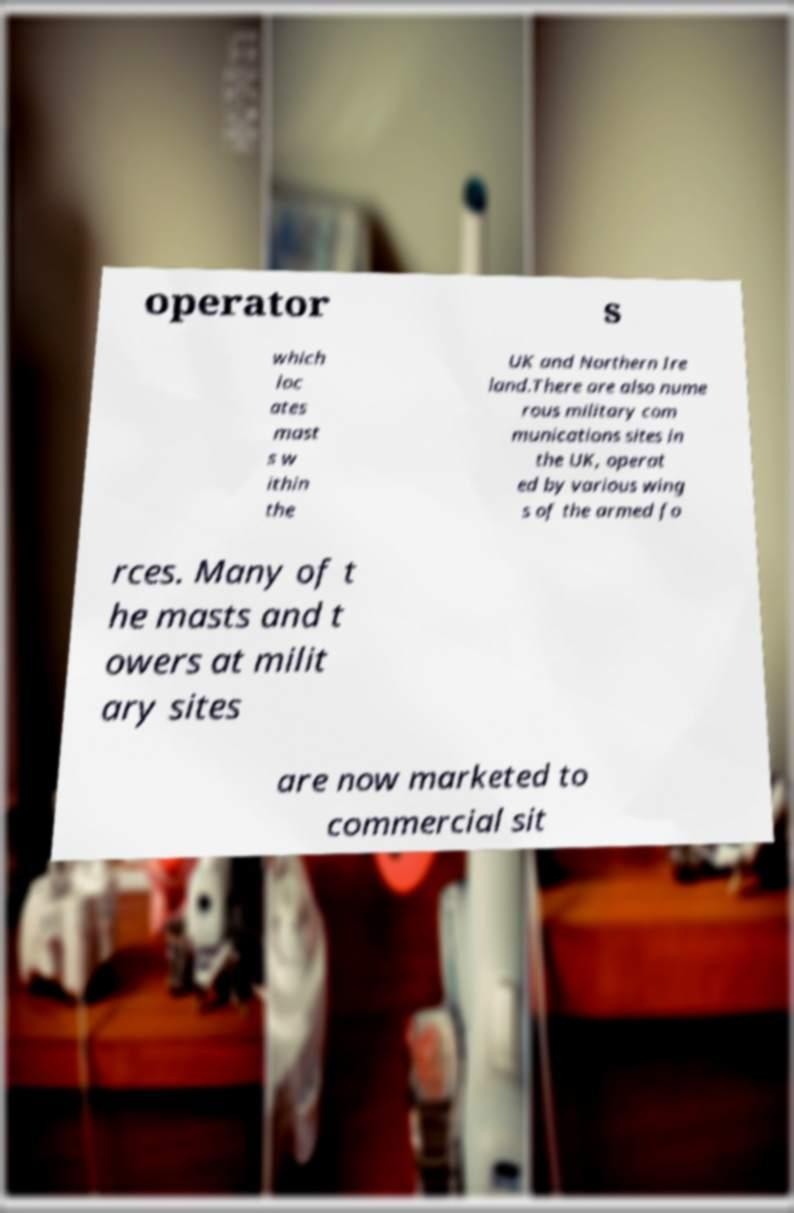Could you assist in decoding the text presented in this image and type it out clearly? operator s which loc ates mast s w ithin the UK and Northern Ire land.There are also nume rous military com munications sites in the UK, operat ed by various wing s of the armed fo rces. Many of t he masts and t owers at milit ary sites are now marketed to commercial sit 